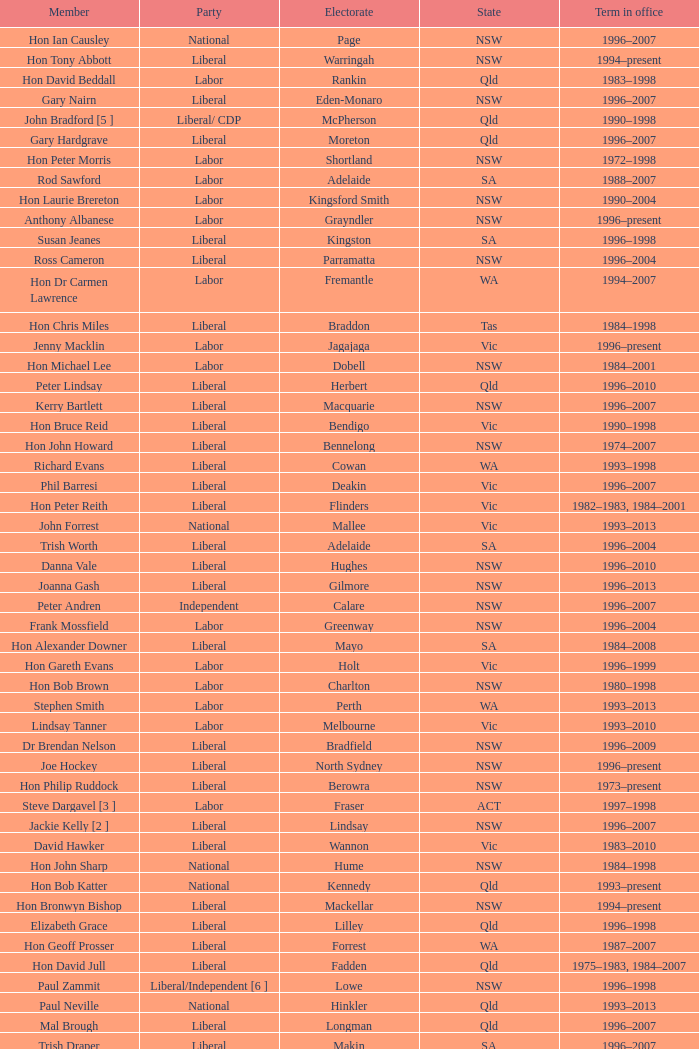What state did Hon David Beddall belong to? Qld. 